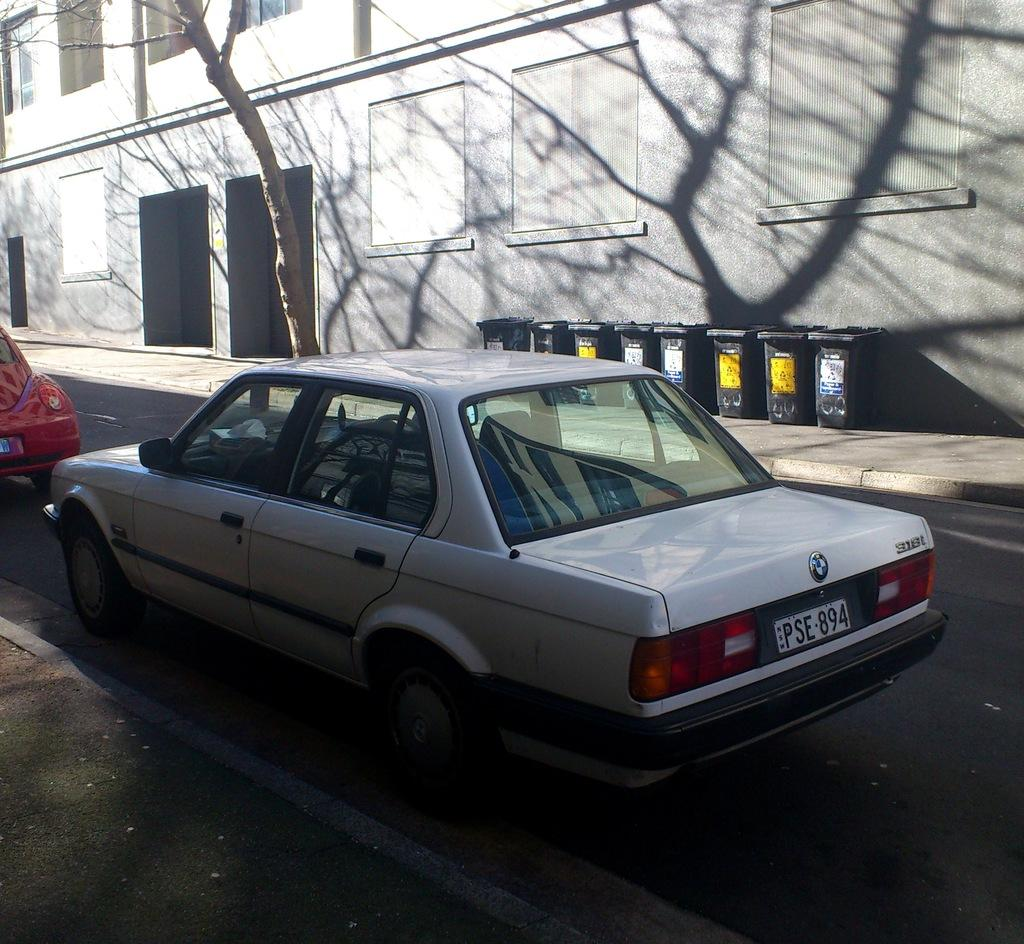How many vehicles can be seen on the road in the image? There are two vehicles on the road in the image. What is the primary feature visible in the image? There is a road visible in the image. What object is present for waste disposal in the image? There is a garbage bin in the image. What type of structure is visible in the image? There is a building in the image. What type of vegetation is present in the image? There is a tree in the image. What type of illumination is present in the image? There are lights in the image. Is there any identification visible on one of the vehicles? Yes, there is a number plate on one of the vehicles. Can you tell me how many elbows are visible in the image? There are no elbows visible in the image. What type of planes can be seen flying in the image? There are no planes present in the image. 